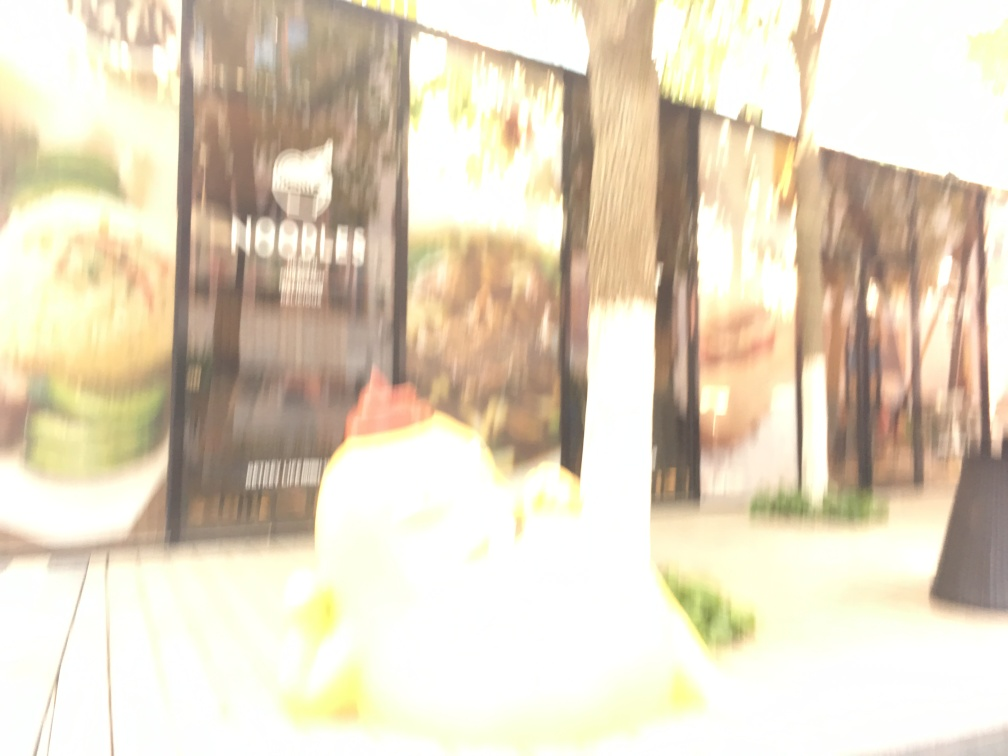What possible subjects or objects might have been intended to be captured clearly in this image? It's difficult to determine the exact subjects due to the blurriness, but this appears to be a street scene, possibly focusing on the dynamics of urban life or storefront displays. The tree and bench suggest it might be a public space possibly intended for capturing the ambiance or the foot traffic in the area. Is there anything in this photo that you can identify with certainty despite the poor quality? Despite the image's compromised quality, we can identify the presence of a tree and outdoor seating, which indicates an urban or semi-urban setting that includes elements designed for public use and enjoyment. 